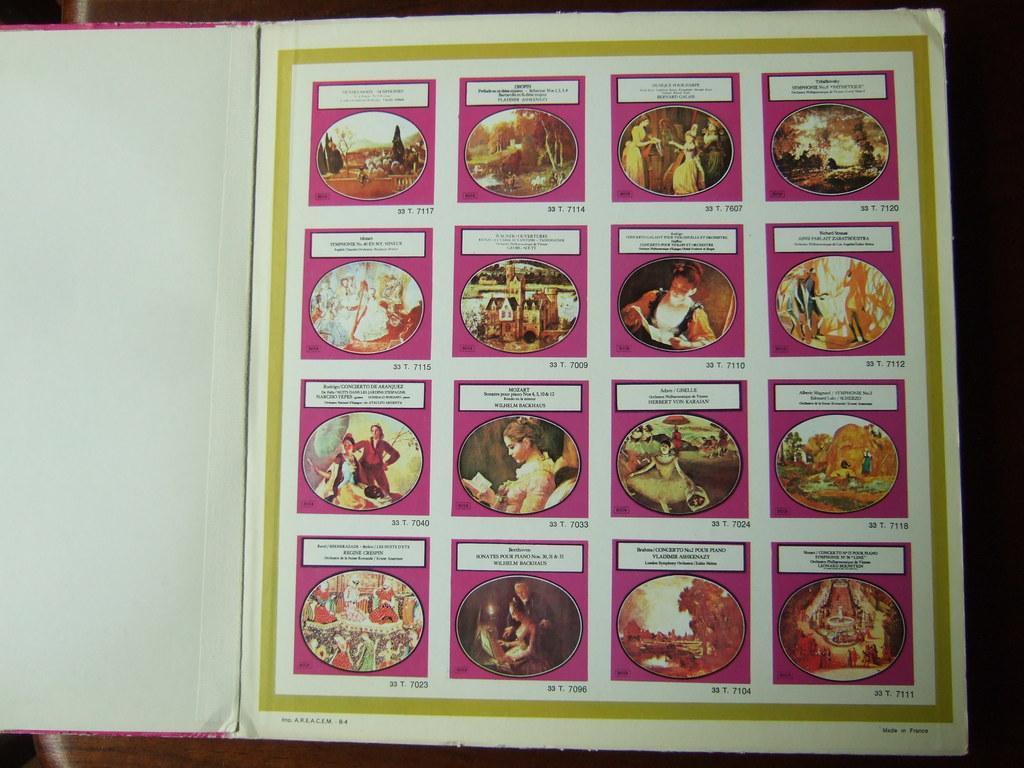Can you describe this image briefly? In this we can find coollarge of images in the book. 